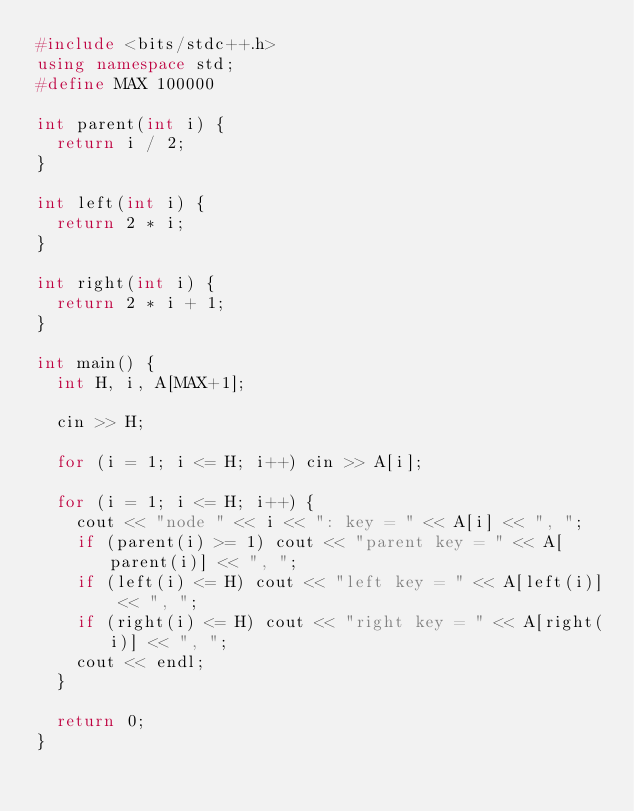<code> <loc_0><loc_0><loc_500><loc_500><_C++_>#include <bits/stdc++.h>
using namespace std;
#define MAX 100000

int parent(int i) {
  return i / 2;
}

int left(int i) {
  return 2 * i;
}

int right(int i) {
  return 2 * i + 1;
}

int main() {
  int H, i, A[MAX+1];

  cin >> H;

  for (i = 1; i <= H; i++) cin >> A[i];

  for (i = 1; i <= H; i++) {
    cout << "node " << i << ": key = " << A[i] << ", ";
    if (parent(i) >= 1) cout << "parent key = " << A[parent(i)] << ", ";
    if (left(i) <= H) cout << "left key = " << A[left(i)] << ", ";
    if (right(i) <= H) cout << "right key = " << A[right(i)] << ", ";
    cout << endl;
  }

  return 0;
}
</code> 